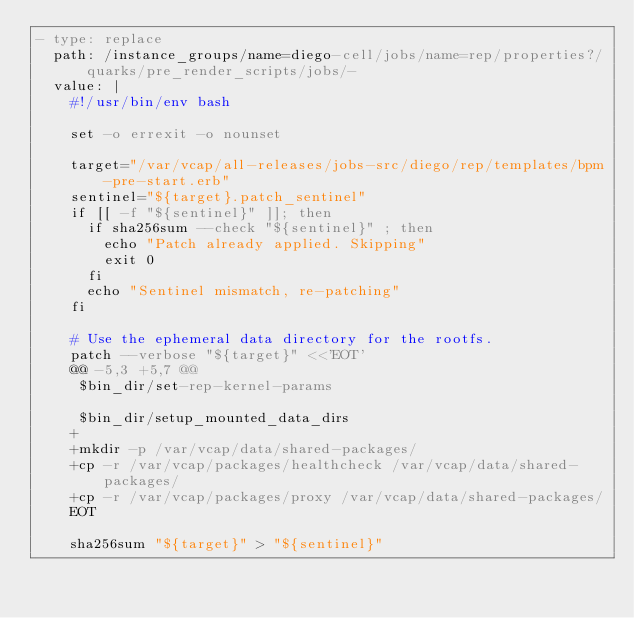Convert code to text. <code><loc_0><loc_0><loc_500><loc_500><_YAML_>- type: replace
  path: /instance_groups/name=diego-cell/jobs/name=rep/properties?/quarks/pre_render_scripts/jobs/-
  value: |
    #!/usr/bin/env bash
    
    set -o errexit -o nounset
    
    target="/var/vcap/all-releases/jobs-src/diego/rep/templates/bpm-pre-start.erb"
    sentinel="${target}.patch_sentinel"
    if [[ -f "${sentinel}" ]]; then
      if sha256sum --check "${sentinel}" ; then
        echo "Patch already applied. Skipping"
        exit 0
      fi
      echo "Sentinel mismatch, re-patching"
    fi
    
    # Use the ephemeral data directory for the rootfs.
    patch --verbose "${target}" <<'EOT'
    @@ -5,3 +5,7 @@
     $bin_dir/set-rep-kernel-params
    
     $bin_dir/setup_mounted_data_dirs
    +
    +mkdir -p /var/vcap/data/shared-packages/
    +cp -r /var/vcap/packages/healthcheck /var/vcap/data/shared-packages/
    +cp -r /var/vcap/packages/proxy /var/vcap/data/shared-packages/
    EOT
    
    sha256sum "${target}" > "${sentinel}"
</code> 